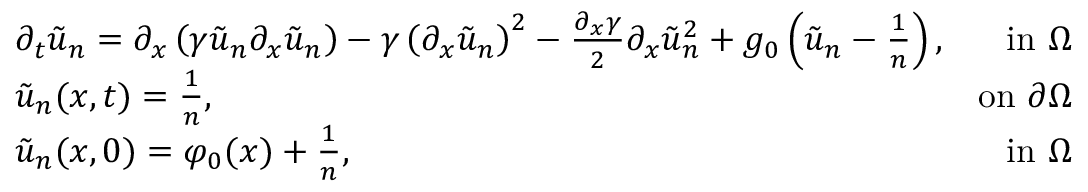Convert formula to latex. <formula><loc_0><loc_0><loc_500><loc_500>\begin{array} { r l r } & { \partial _ { t } \tilde { u } _ { n } = \partial _ { x } \left ( \gamma \tilde { u } _ { n } \partial _ { x } \tilde { u } _ { n } \right ) - \gamma \left ( \partial _ { x } \tilde { u } _ { n } \right ) ^ { 2 } - \frac { \partial _ { x } \gamma } { 2 } \partial _ { x } \tilde { u } _ { n } ^ { 2 } + g _ { 0 } \left ( \tilde { u } _ { n } - \frac { 1 } { n } \right ) , } & { i n \Omega } \\ & { \tilde { u } _ { n } ( x , t ) = \frac { 1 } { n } , } & { o n \partial \Omega } \\ & { \tilde { u } _ { n } ( x , 0 ) = \varphi _ { 0 } ( x ) + \frac { 1 } { n } , } & { i n \Omega } \end{array}</formula> 